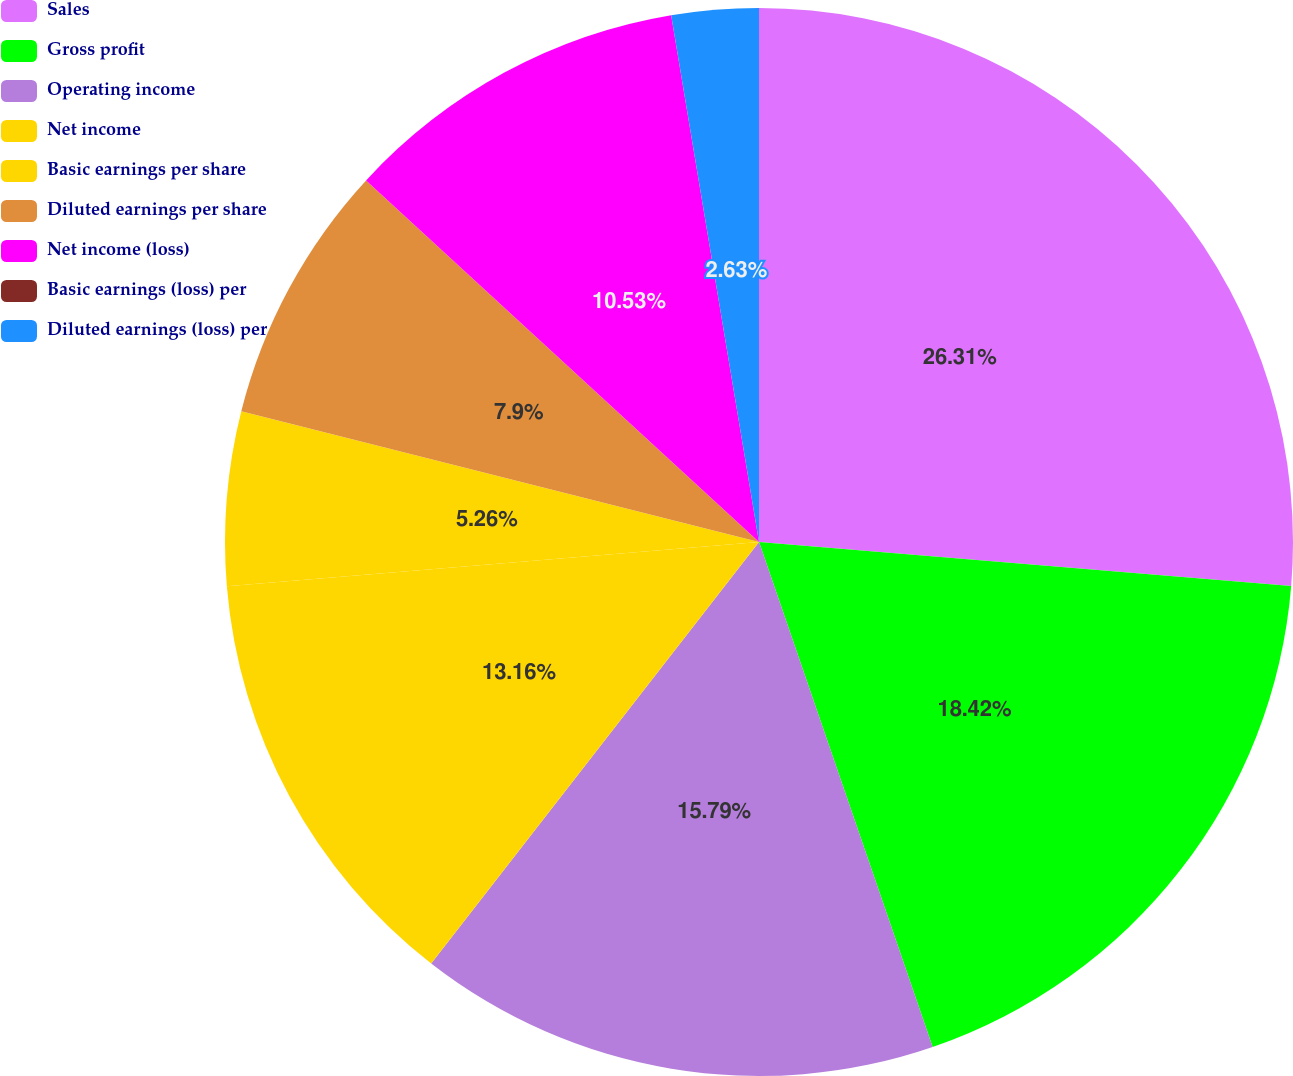Convert chart. <chart><loc_0><loc_0><loc_500><loc_500><pie_chart><fcel>Sales<fcel>Gross profit<fcel>Operating income<fcel>Net income<fcel>Basic earnings per share<fcel>Diluted earnings per share<fcel>Net income (loss)<fcel>Basic earnings (loss) per<fcel>Diluted earnings (loss) per<nl><fcel>26.31%<fcel>18.42%<fcel>15.79%<fcel>13.16%<fcel>5.26%<fcel>7.9%<fcel>10.53%<fcel>0.0%<fcel>2.63%<nl></chart> 